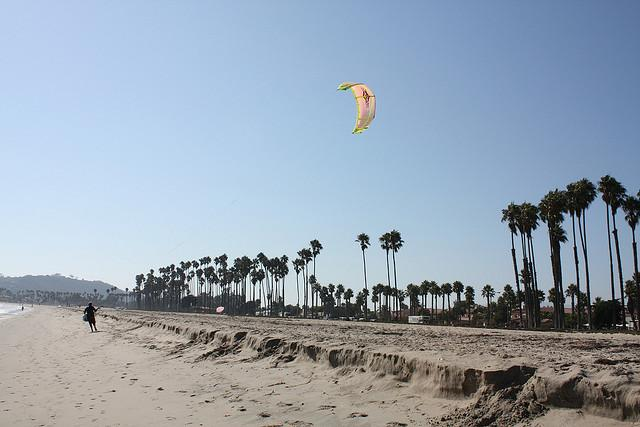What sport can be associated with the above picture?

Choices:
A) wake boarding
B) paragliding
C) surfing
D) sailing paragliding 